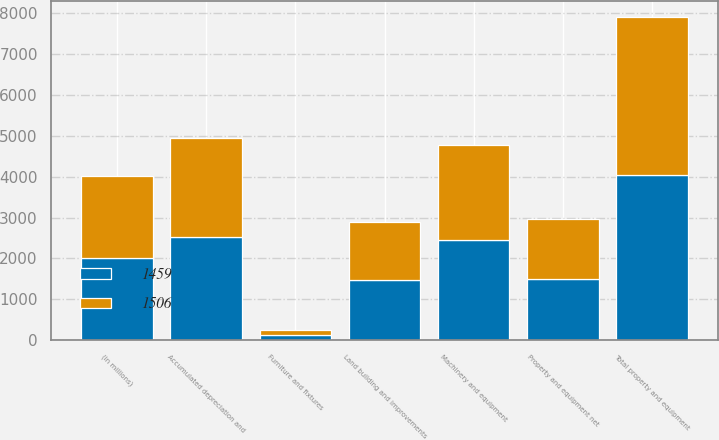Convert chart to OTSL. <chart><loc_0><loc_0><loc_500><loc_500><stacked_bar_chart><ecel><fcel>(in millions)<fcel>Land building and improvements<fcel>Machinery and equipment<fcel>Furniture and fixtures<fcel>Total property and equipment<fcel>Accumulated depreciation and<fcel>Property and equipment net<nl><fcel>1459<fcel>2015<fcel>1465<fcel>2440<fcel>129<fcel>4034<fcel>2528<fcel>1506<nl><fcel>1506<fcel>2014<fcel>1419<fcel>2326<fcel>125<fcel>3870<fcel>2411<fcel>1459<nl></chart> 